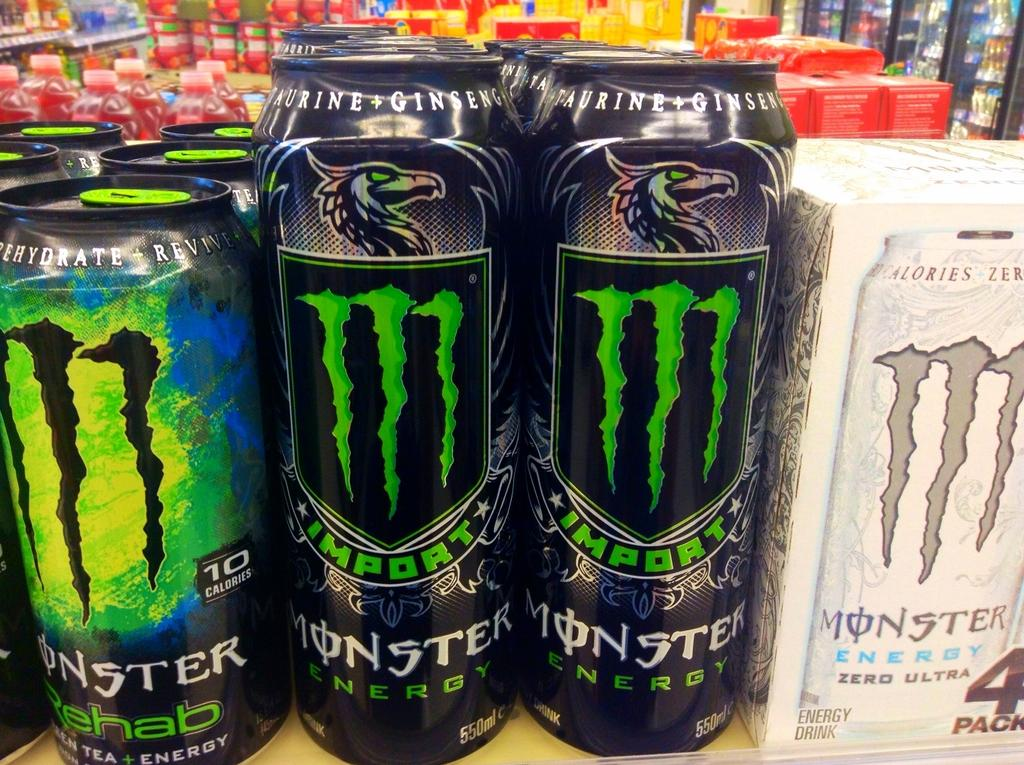<image>
Create a compact narrative representing the image presented. Many varieties of Monster Energy drink sit on a shelf. 